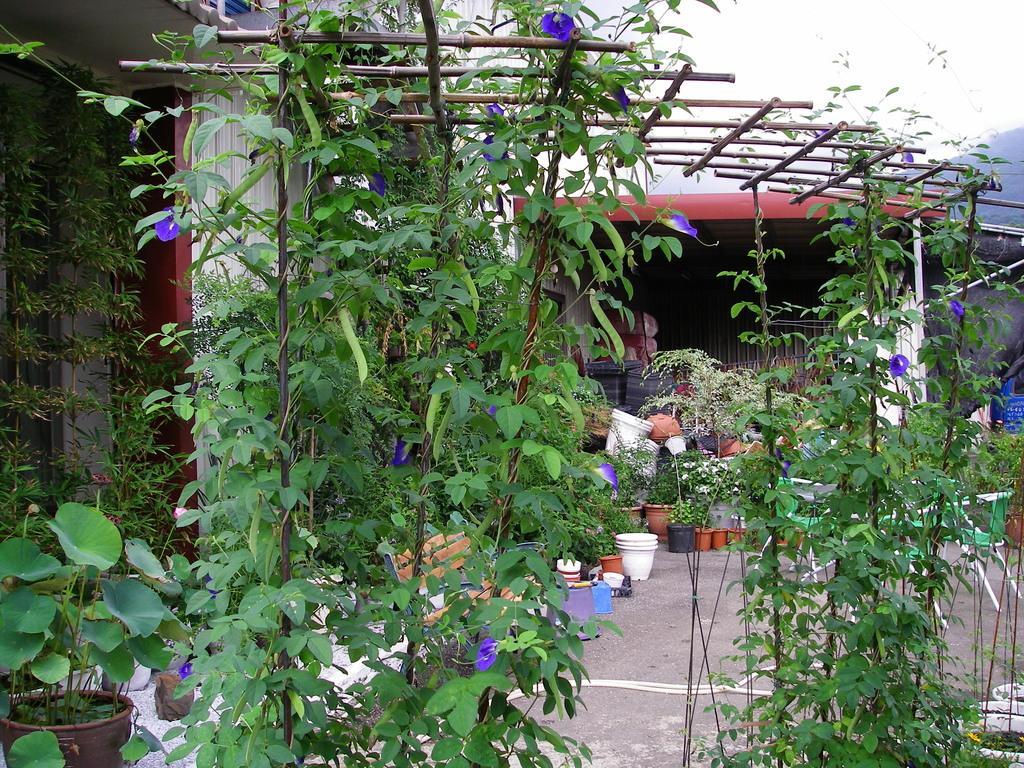Describe this image in one or two sentences. In this picture we can see a bench, pots on the ground, plants, sticks and in the background we can see some objects. 